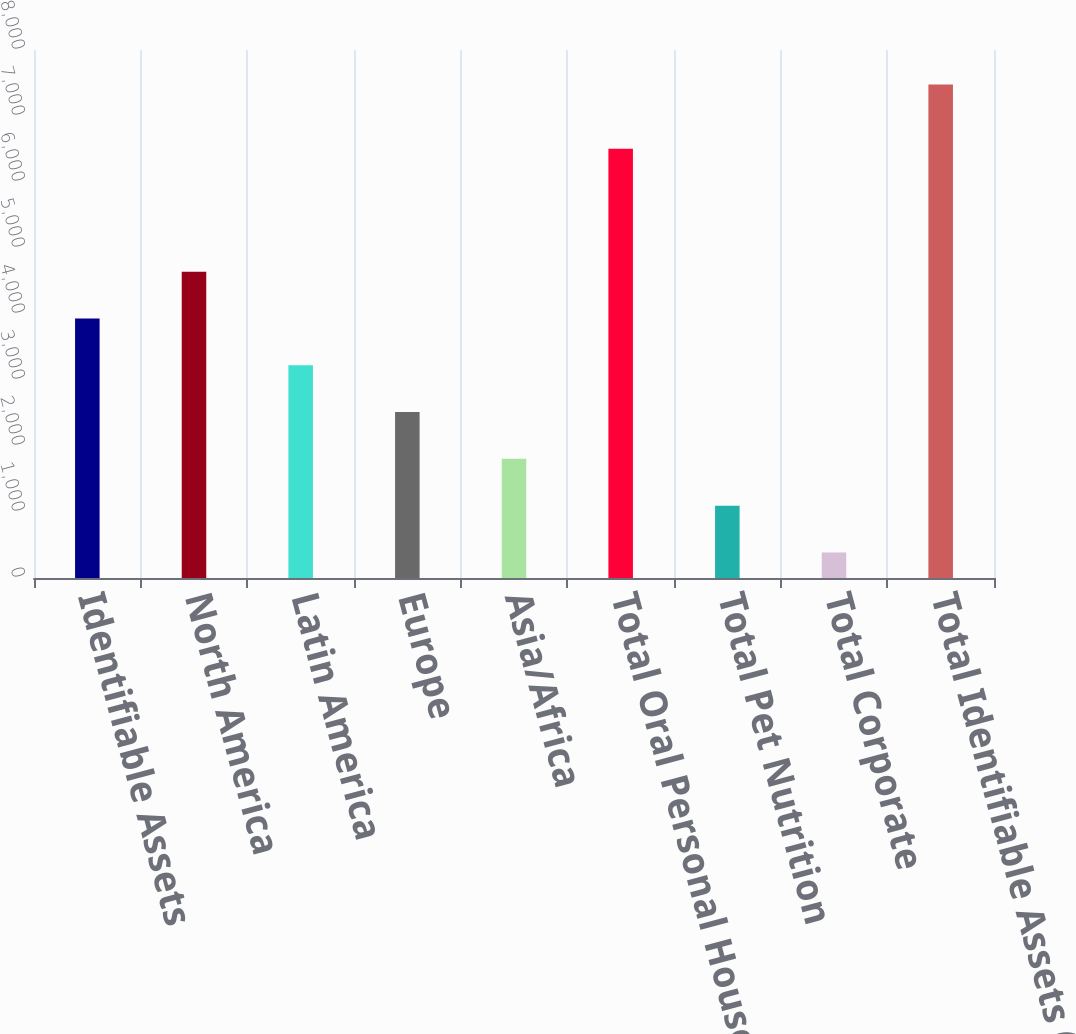Convert chart. <chart><loc_0><loc_0><loc_500><loc_500><bar_chart><fcel>Identifiable Assets<fcel>North America<fcel>Latin America<fcel>Europe<fcel>Asia/Africa<fcel>Total Oral Personal Household<fcel>Total Pet Nutrition<fcel>Total Corporate<fcel>Total Identifiable Assets (1)<nl><fcel>3932.65<fcel>4641.88<fcel>3223.42<fcel>2514.19<fcel>1804.96<fcel>6505.1<fcel>1095.73<fcel>386.5<fcel>7478.8<nl></chart> 